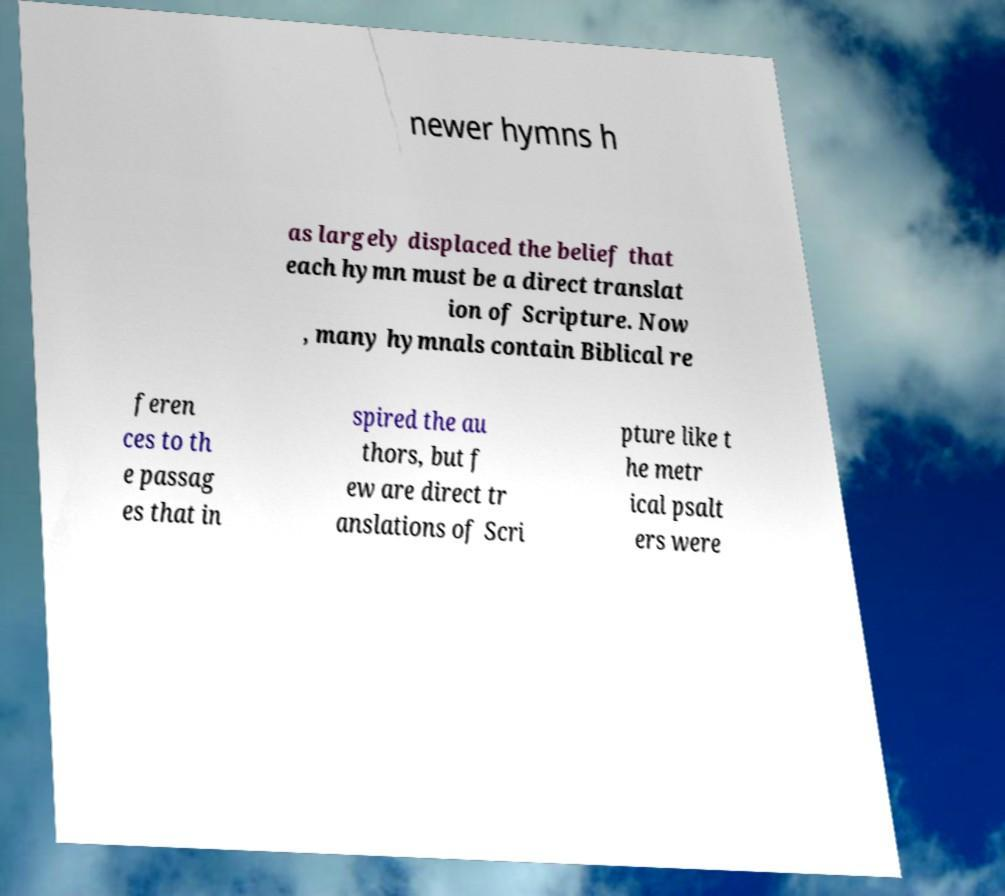Could you extract and type out the text from this image? newer hymns h as largely displaced the belief that each hymn must be a direct translat ion of Scripture. Now , many hymnals contain Biblical re feren ces to th e passag es that in spired the au thors, but f ew are direct tr anslations of Scri pture like t he metr ical psalt ers were 